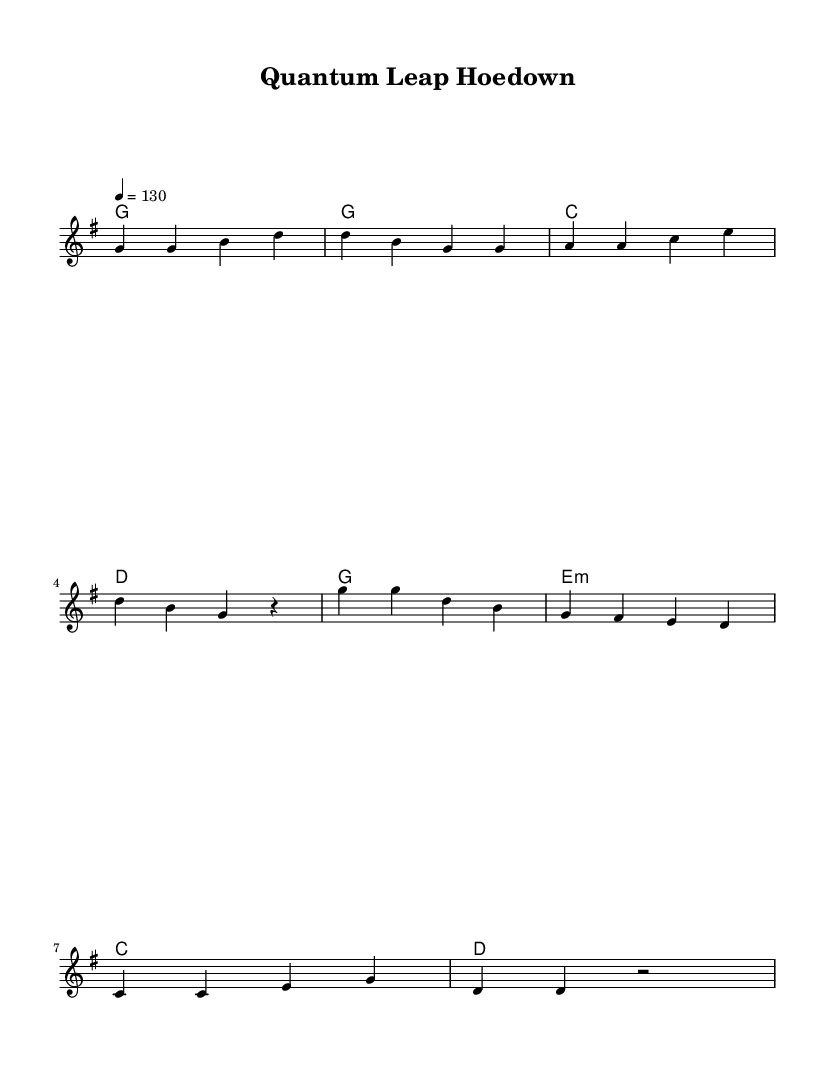What is the key signature of this music? The key signature is G major, which has one sharp (F#).
Answer: G major What is the time signature of this music? The time signature is 4/4, indicating four beats in a measure.
Answer: 4/4 What is the tempo marking for this piece? The tempo marking is 130 beats per minute, which is indicated by the tempo text.
Answer: 130 How many measures are in the verse segment? The verse consists of four measures as indicated by the notation before the chorus.
Answer: 4 What type of chord is used in the chorus starting with the first chord? The first chord in the chorus is E minor, indicated by the lowercase "m".
Answer: E minor What is the overall theme of the lyrics in this piece? The lyrics celebrate scientific breakthroughs, with a specific mention of "quantum leap."
Answer: Science How does the structure of the song reflect typical country rock elements? The song features a repetitive melody and catchy chorus, hallmarks of country rock, while also integrating science themes.
Answer: Repetitive melody and catchy chorus 